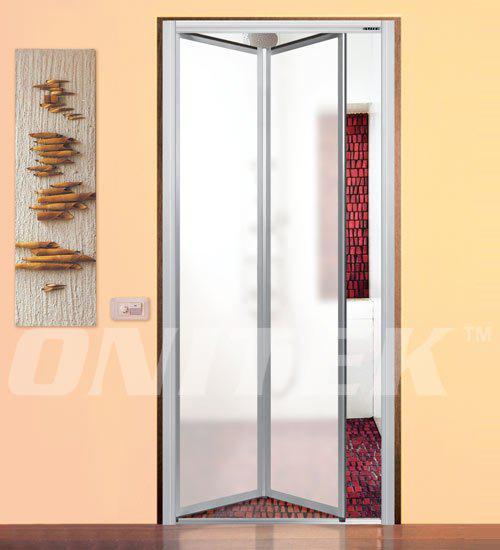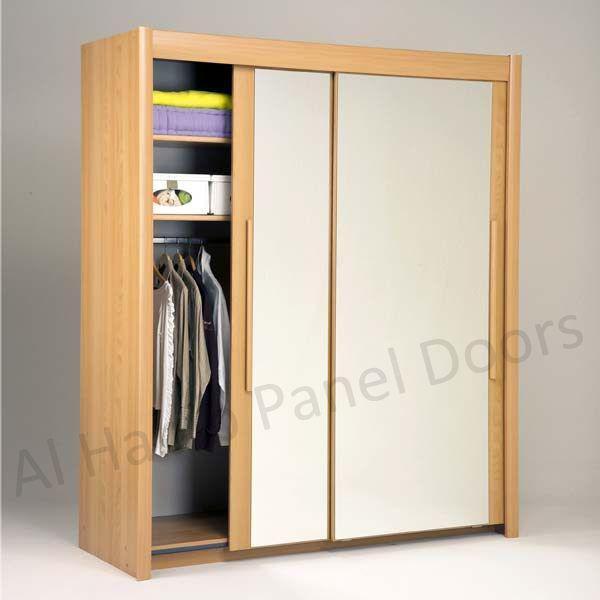The first image is the image on the left, the second image is the image on the right. Evaluate the accuracy of this statement regarding the images: "At least one set of doors opens with a gap in the center.". Is it true? Answer yes or no. No. The first image is the image on the left, the second image is the image on the right. For the images shown, is this caption "In one image, a door leading to a room has two panels, one of them partially open." true? Answer yes or no. No. 